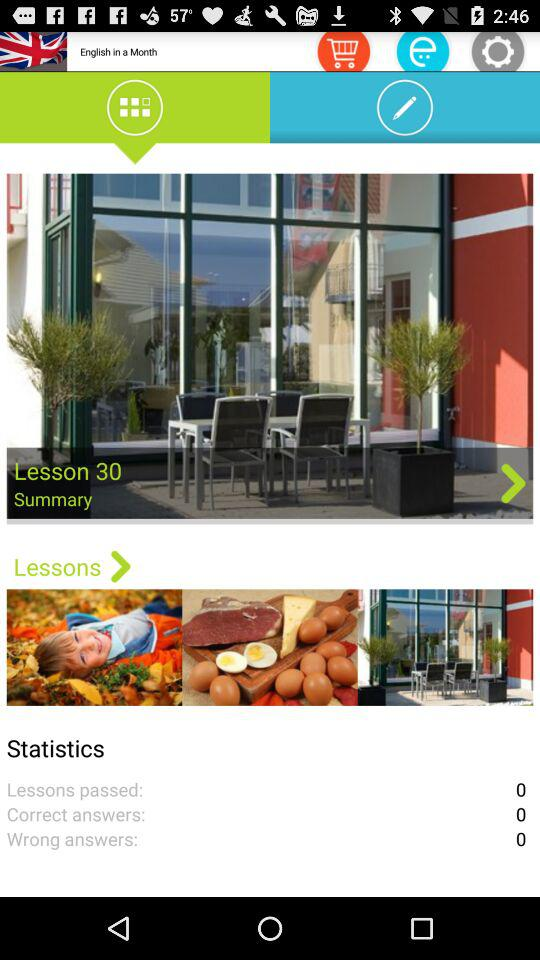How many lessons have passed? The number of lessons that have passed is 0. 